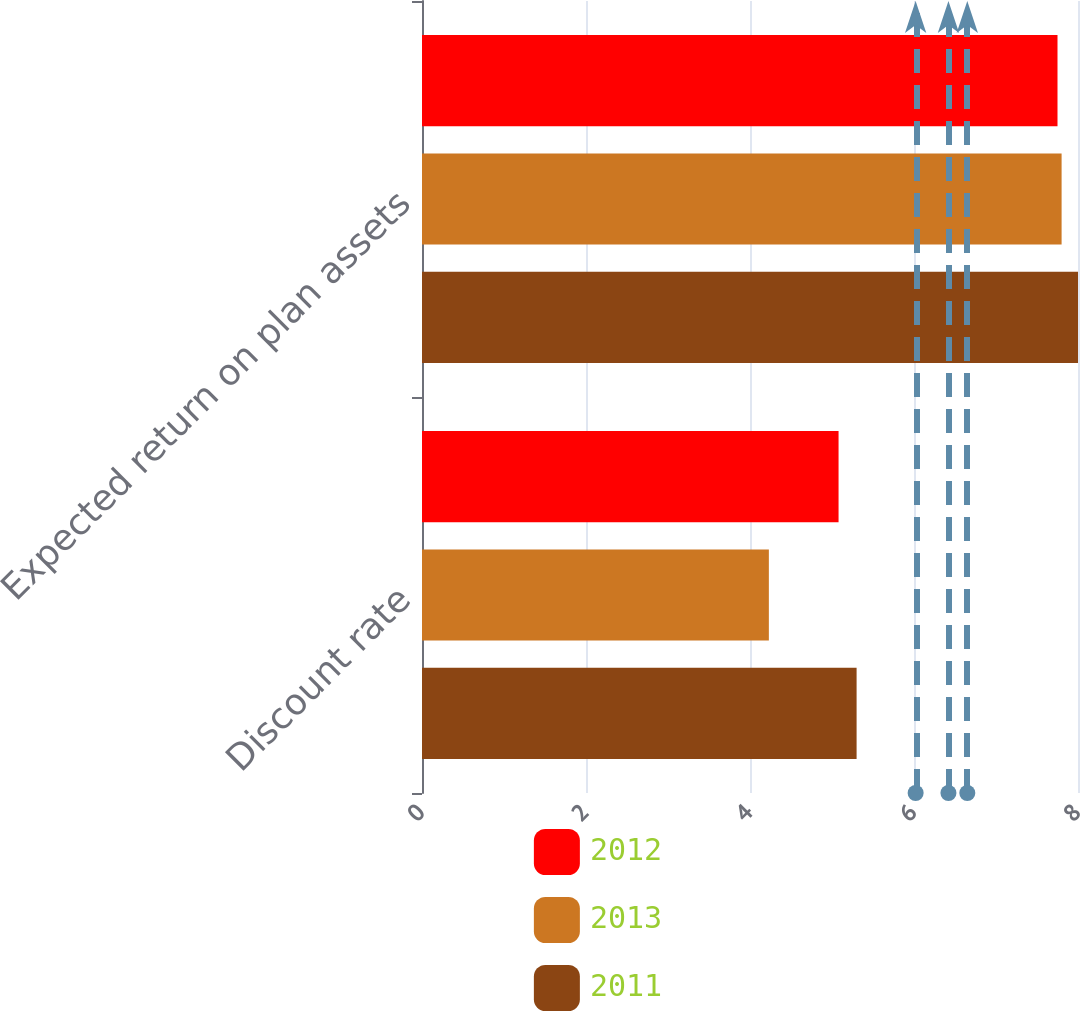<chart> <loc_0><loc_0><loc_500><loc_500><stacked_bar_chart><ecel><fcel>Discount rate<fcel>Expected return on plan assets<nl><fcel>2012<fcel>5.08<fcel>7.75<nl><fcel>2013<fcel>4.23<fcel>7.8<nl><fcel>2011<fcel>5.3<fcel>8<nl></chart> 